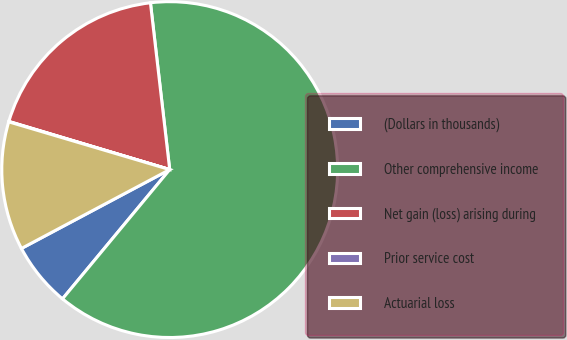<chart> <loc_0><loc_0><loc_500><loc_500><pie_chart><fcel>(Dollars in thousands)<fcel>Other comprehensive income<fcel>Net gain (loss) arising during<fcel>Prior service cost<fcel>Actuarial loss<nl><fcel>6.2%<fcel>62.85%<fcel>18.54%<fcel>0.04%<fcel>12.37%<nl></chart> 